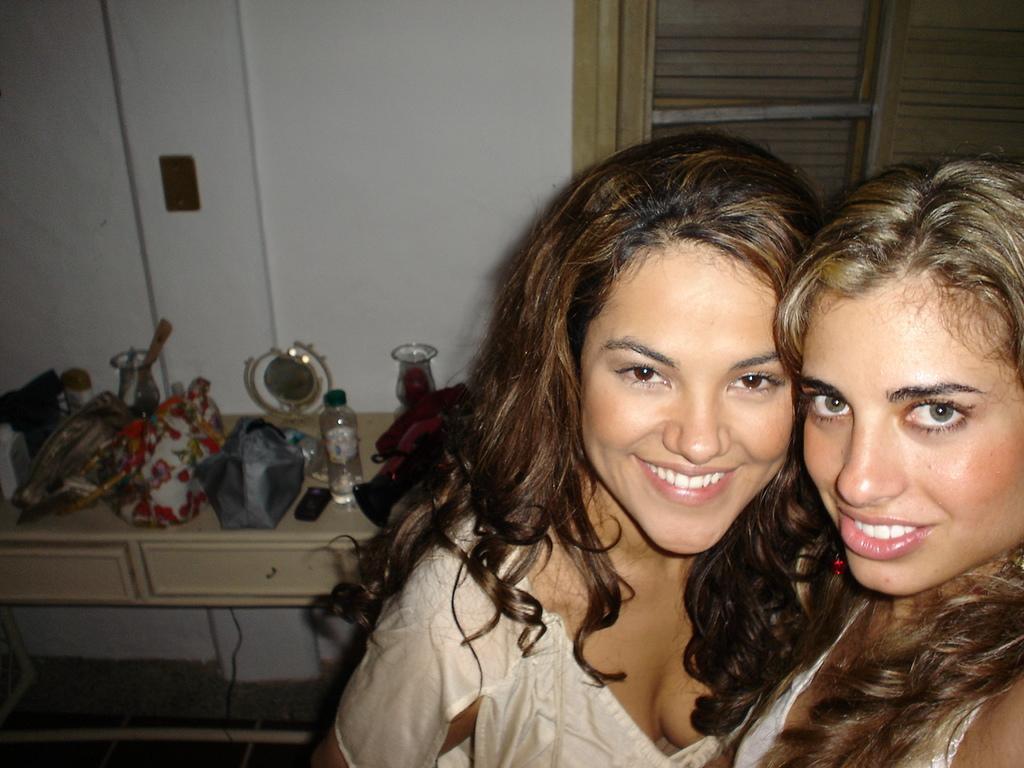Describe this image in one or two sentences. In this picture we can see two woman smiling and beside to them there is table and on table we can see bottle, bags, jar, some shield, racks and in background we can see wall, window. 